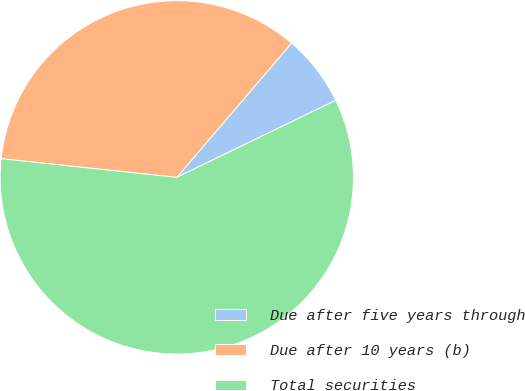Convert chart. <chart><loc_0><loc_0><loc_500><loc_500><pie_chart><fcel>Due after five years through<fcel>Due after 10 years (b)<fcel>Total securities<nl><fcel>6.56%<fcel>34.57%<fcel>58.87%<nl></chart> 